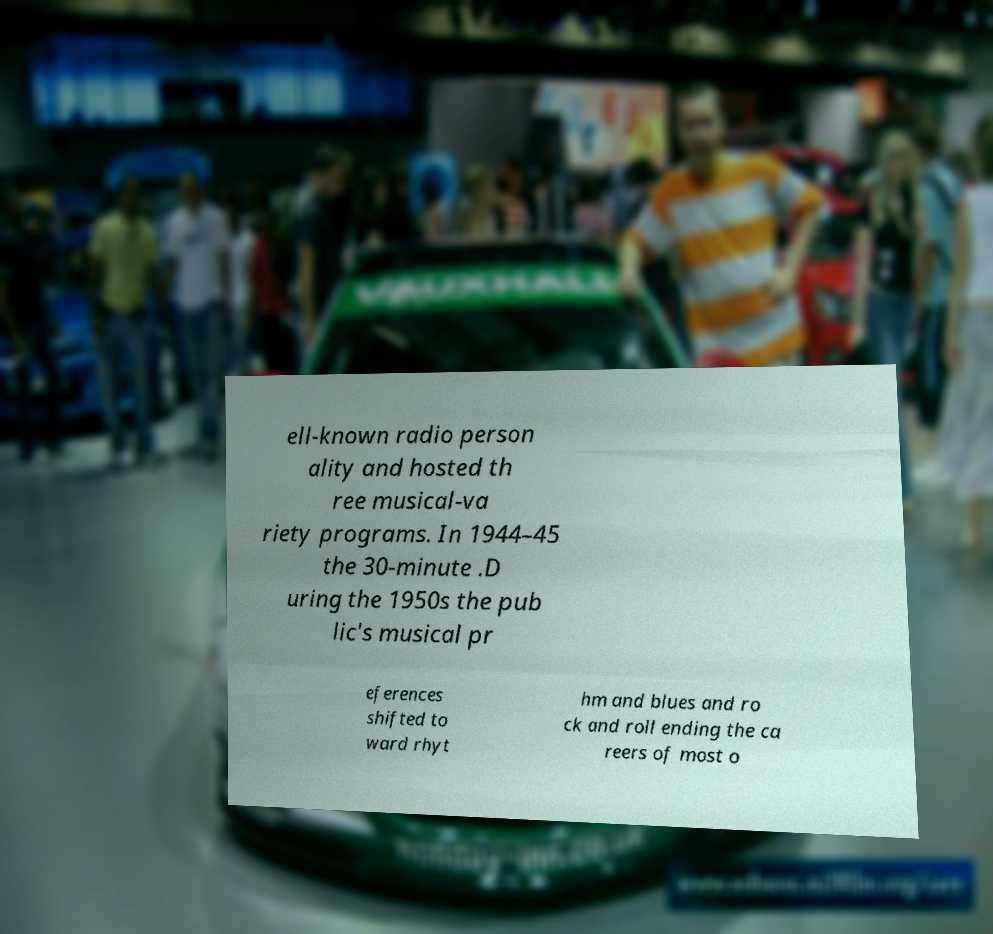For documentation purposes, I need the text within this image transcribed. Could you provide that? ell-known radio person ality and hosted th ree musical-va riety programs. In 1944–45 the 30-minute .D uring the 1950s the pub lic's musical pr eferences shifted to ward rhyt hm and blues and ro ck and roll ending the ca reers of most o 